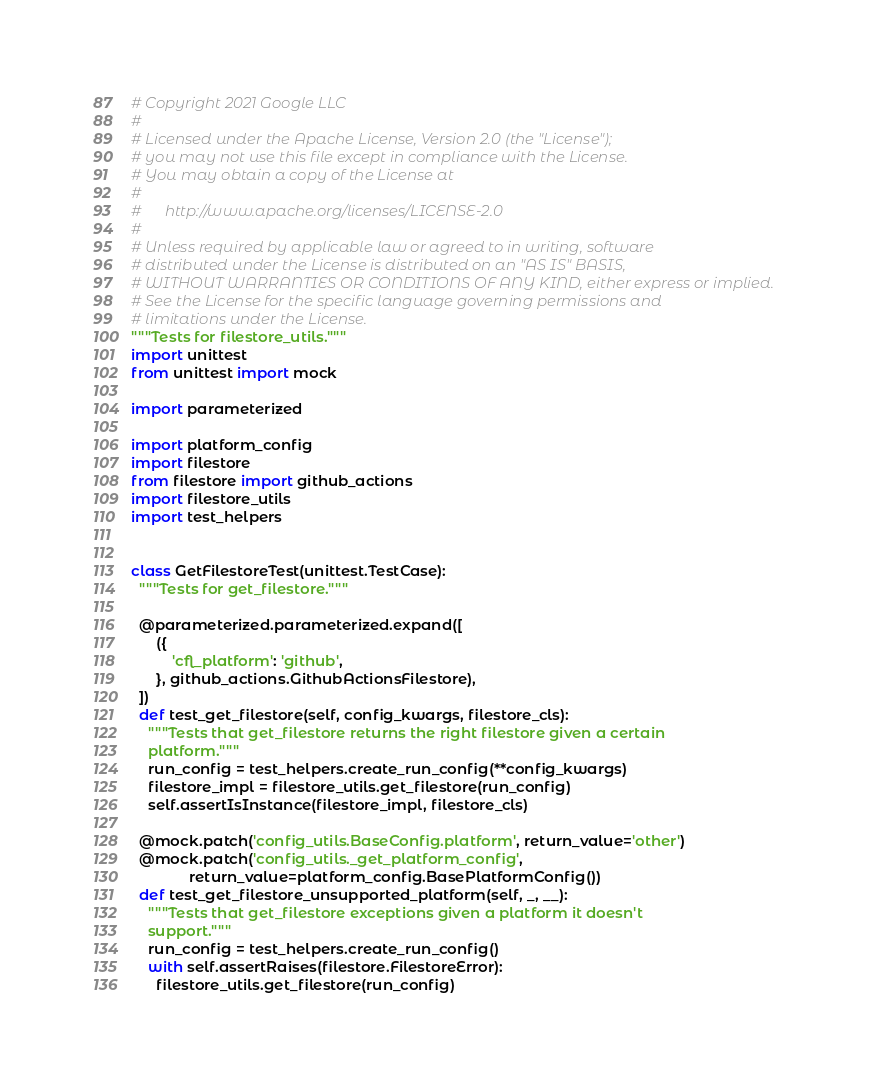Convert code to text. <code><loc_0><loc_0><loc_500><loc_500><_Python_># Copyright 2021 Google LLC
#
# Licensed under the Apache License, Version 2.0 (the "License");
# you may not use this file except in compliance with the License.
# You may obtain a copy of the License at
#
#      http://www.apache.org/licenses/LICENSE-2.0
#
# Unless required by applicable law or agreed to in writing, software
# distributed under the License is distributed on an "AS IS" BASIS,
# WITHOUT WARRANTIES OR CONDITIONS OF ANY KIND, either express or implied.
# See the License for the specific language governing permissions and
# limitations under the License.
"""Tests for filestore_utils."""
import unittest
from unittest import mock

import parameterized

import platform_config
import filestore
from filestore import github_actions
import filestore_utils
import test_helpers


class GetFilestoreTest(unittest.TestCase):
  """Tests for get_filestore."""

  @parameterized.parameterized.expand([
      ({
          'cfl_platform': 'github',
      }, github_actions.GithubActionsFilestore),
  ])
  def test_get_filestore(self, config_kwargs, filestore_cls):
    """Tests that get_filestore returns the right filestore given a certain
    platform."""
    run_config = test_helpers.create_run_config(**config_kwargs)
    filestore_impl = filestore_utils.get_filestore(run_config)
    self.assertIsInstance(filestore_impl, filestore_cls)

  @mock.patch('config_utils.BaseConfig.platform', return_value='other')
  @mock.patch('config_utils._get_platform_config',
              return_value=platform_config.BasePlatformConfig())
  def test_get_filestore_unsupported_platform(self, _, __):
    """Tests that get_filestore exceptions given a platform it doesn't
    support."""
    run_config = test_helpers.create_run_config()
    with self.assertRaises(filestore.FilestoreError):
      filestore_utils.get_filestore(run_config)
</code> 